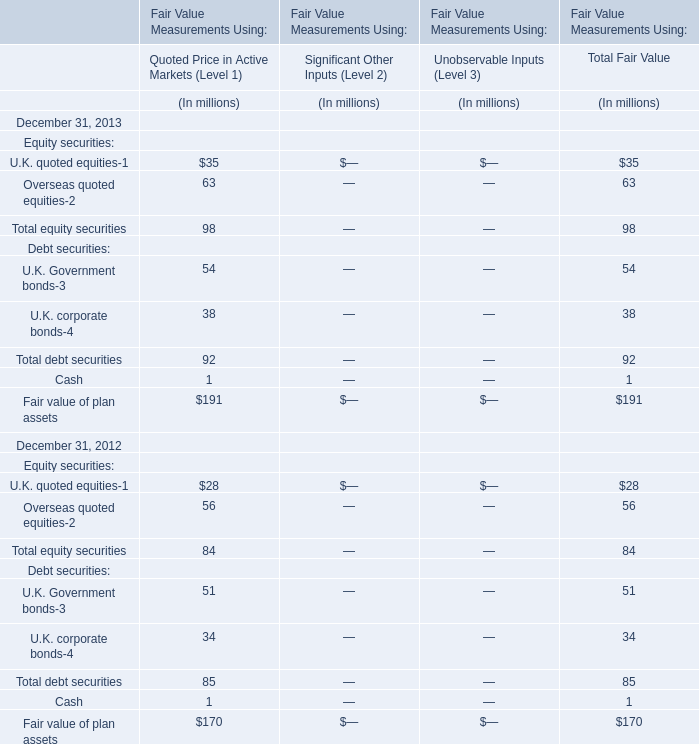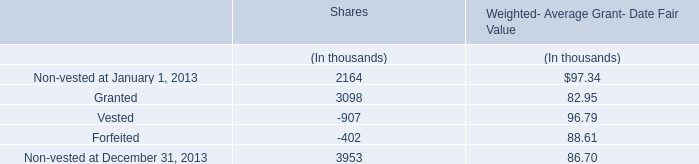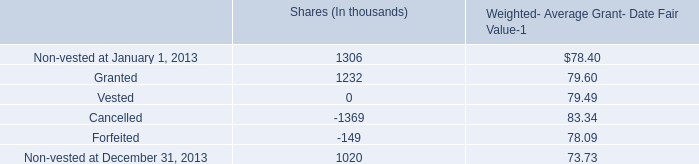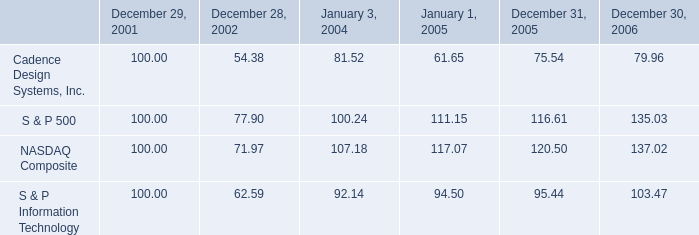what is the rate of return of an investment in s&p500 inc from 2001 to 2005? 
Computations: ((111.15 - 100) / 100)
Answer: 0.1115. 